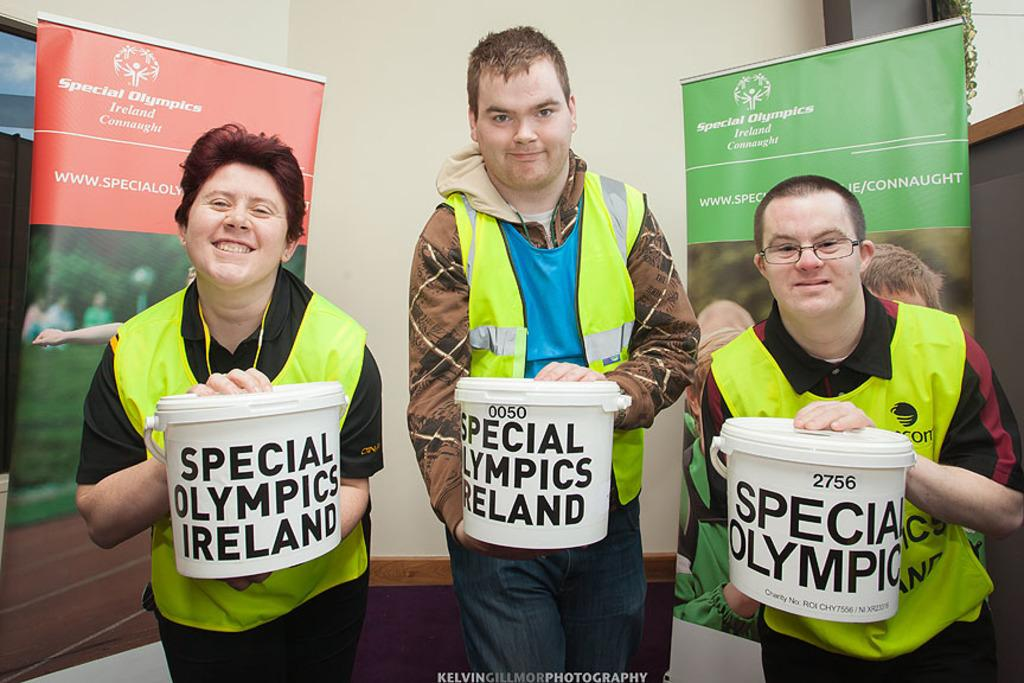How many people are in the image? There are three persons in the image. What are the persons holding in the image? The persons are holding buckets. What can be seen in the background of the image? There are banners and a wall in the background of the image. What type of trees can be seen growing on the silk in the image? There are no trees or silk present in the image. 